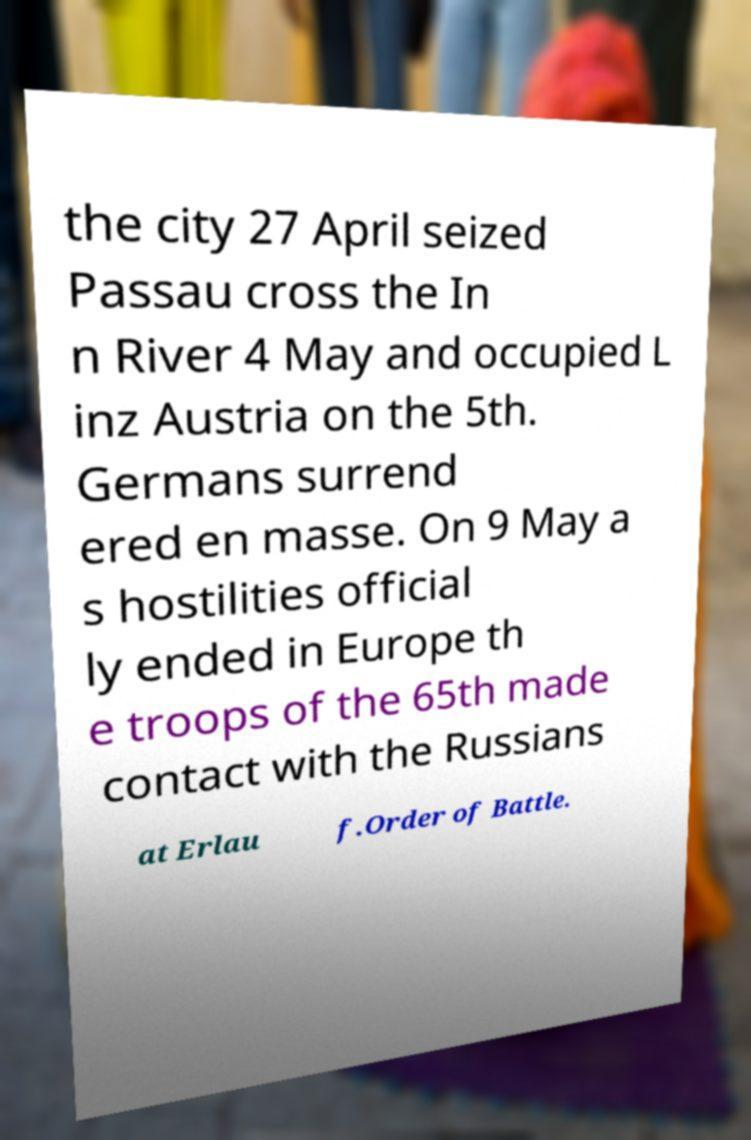Please read and relay the text visible in this image. What does it say? the city 27 April seized Passau cross the In n River 4 May and occupied L inz Austria on the 5th. Germans surrend ered en masse. On 9 May a s hostilities official ly ended in Europe th e troops of the 65th made contact with the Russians at Erlau f.Order of Battle. 